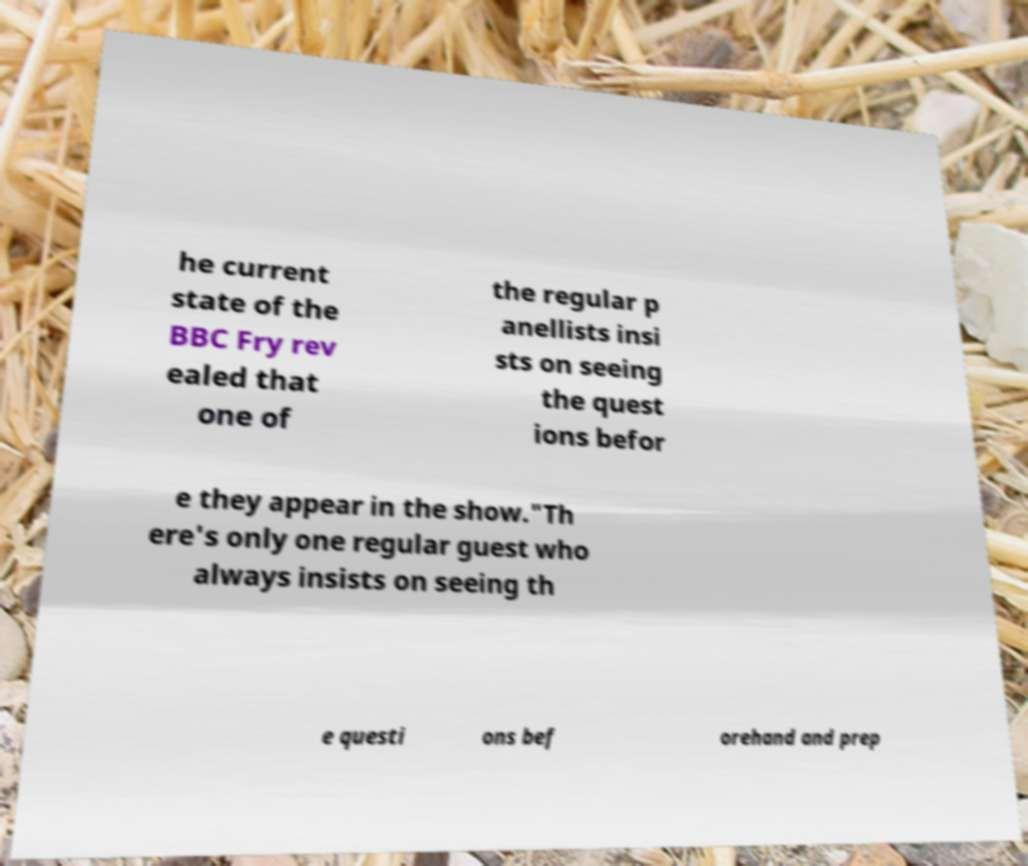Could you assist in decoding the text presented in this image and type it out clearly? he current state of the BBC Fry rev ealed that one of the regular p anellists insi sts on seeing the quest ions befor e they appear in the show."Th ere's only one regular guest who always insists on seeing th e questi ons bef orehand and prep 